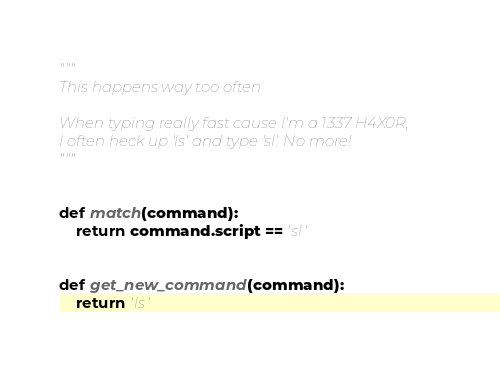Convert code to text. <code><loc_0><loc_0><loc_500><loc_500><_Python_>"""
This happens way too often

When typing really fast cause I'm a 1337 H4X0R,
I often heck up 'ls' and type 'sl'. No more!
"""


def match(command):
    return command.script == 'sl'


def get_new_command(command):
    return 'ls'
</code> 